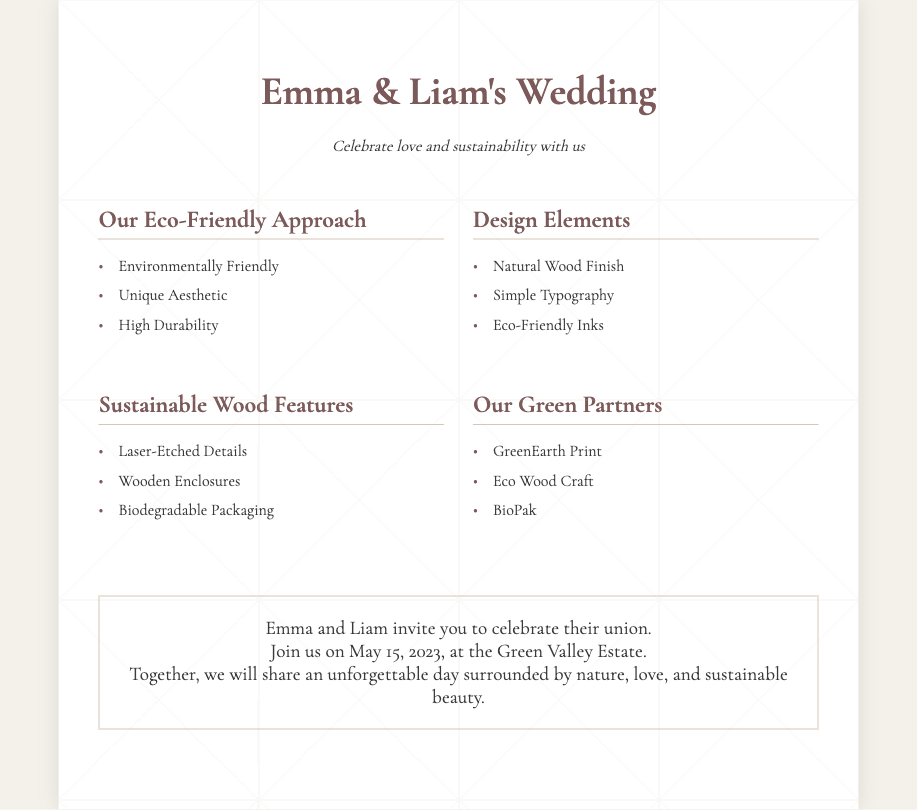What is the couple's name? The couple's name is prominently displayed at the top of the invitation as Emma and Liam.
Answer: Emma & Liam What is the date of the wedding? The wedding date is mentioned in the invitation text as May 15, 2023.
Answer: May 15, 2023 Where will the wedding take place? The location of the wedding is stated as the Green Valley Estate.
Answer: Green Valley Estate What is one element of the eco-friendly approach? The eco-friendly approach highlights multiple elements, one being "Environmentally Friendly."
Answer: Environmentally Friendly What type of packaging is used for the invitations? The sustainable wood features include "Biodegradable Packaging."
Answer: Biodegradable Packaging Which company is listed as a green partner? Among the green partners, "GreenEarth Print" is mentioned.
Answer: GreenEarth Print What is a key design element of the invitations? The design elements include "Natural Wood Finish."
Answer: Natural Wood Finish What is the purpose of the gathering? The purpose of the gathering is to celebrate the union of Emma and Liam.
Answer: Celebrate their union How does the invitation emphasize its theme? The invitation emphasizes its theme through the phrase "Celebrate love and sustainability."
Answer: Celebrate love and sustainability 